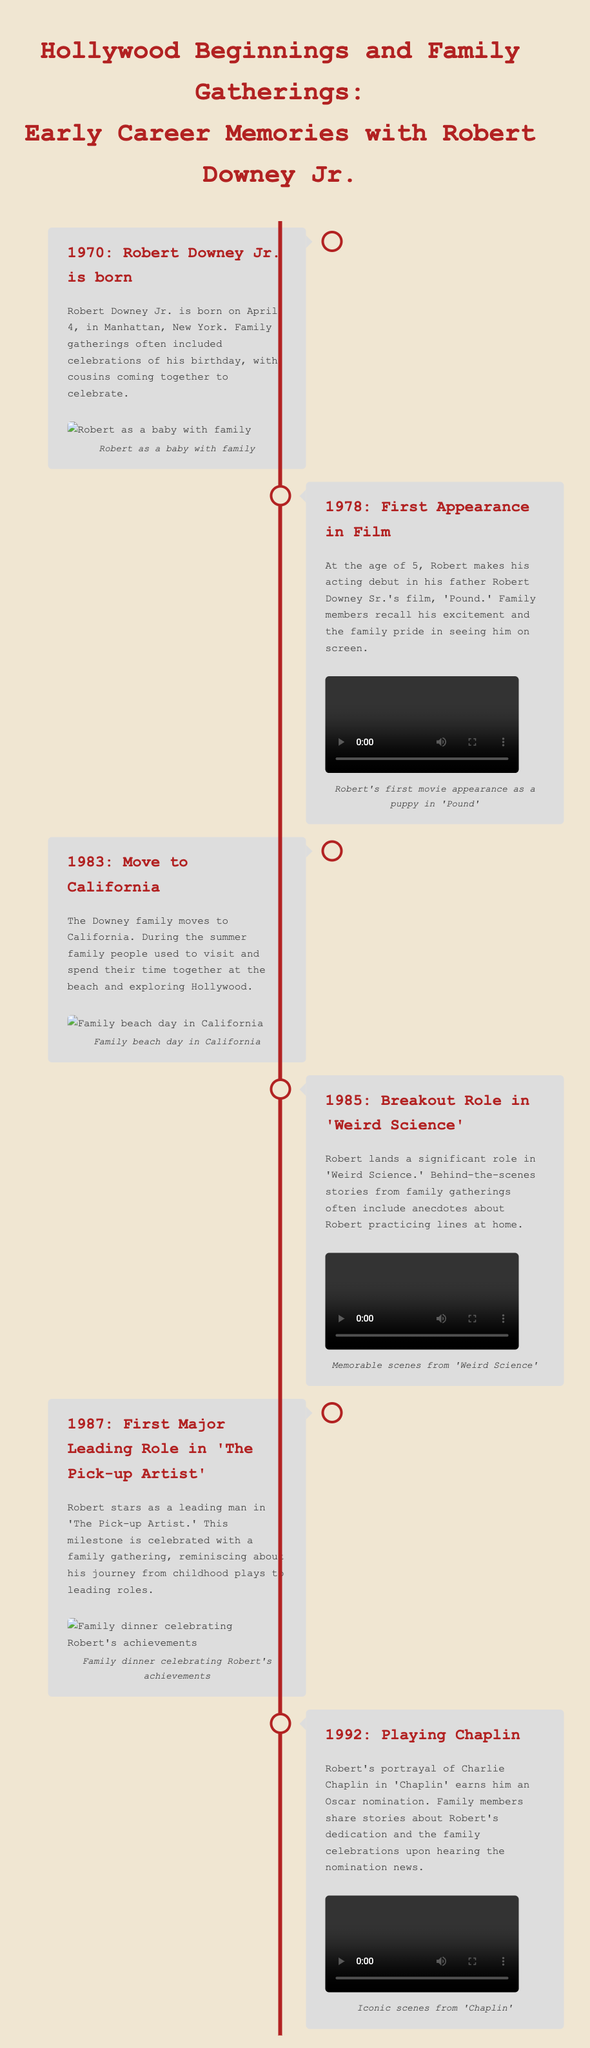What year was Robert Downey Jr. born? The document states that Robert was born in 1970.
Answer: 1970 In which film did Robert make his acting debut? The document mentions his debut film was 'Pound.'
Answer: Pound What significant role did Robert land in 1985? According to the document, he had a significant role in 'Weird Science.'
Answer: Weird Science What family event commemorated Robert's first major leading role? The document notes that a family gathering celebrated Robert's leading role in 'The Pick-up Artist.'
Answer: Family gathering What milestone occurred in 1992 related to Robert's acting career? The document indicates he received an Oscar nomination for 'Chaplin.'
Answer: Oscar nomination How old was Robert when he appeared in his first film? The document specifies he was 5 years old.
Answer: 5 What type of gathering is frequently mentioned in relation to Robert's acting milestones? The document refers to family gatherings as a recurrent theme.
Answer: Family gatherings What was Robert's notable character portrayal in 'Chaplin'? The document states he portrayed Charlie Chaplin.
Answer: Charlie Chaplin Where did the Downey family move in 1983? The document indicates the family moved to California.
Answer: California 